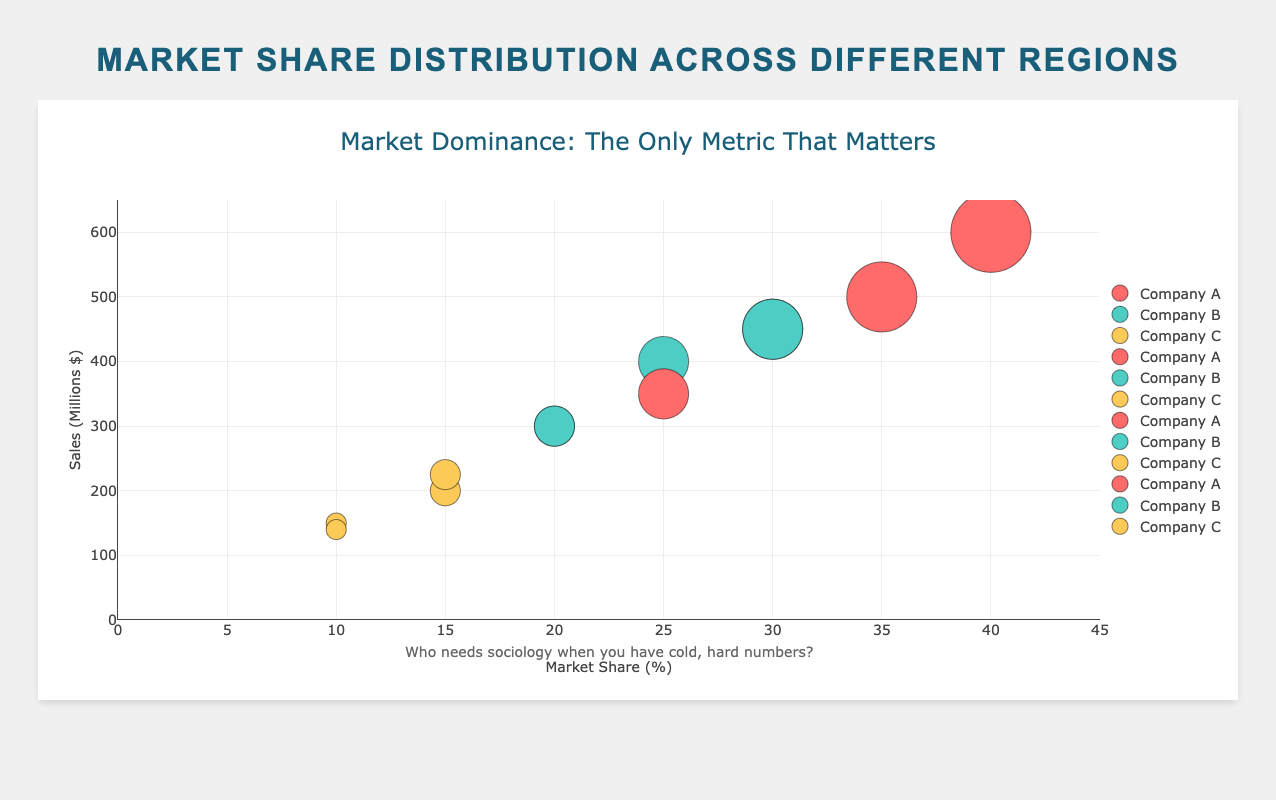What's the title of the bubble chart? The title of the chart is prominently displayed at the top, reading "Market Dominance: The Only Metric That Matters".
Answer: Market Dominance: The Only Metric That Matters What does the x-axis represent? The x-axis title is "Market Share (%)", representing the market share percentage of different companies in various regions.
Answer: Market Share (%) Which company in the "Asia" region has the highest sales? By observing the bubbles for the Asia region, Company A has the largest bubble and its tooltip shows sales of $600M, which is the highest.
Answer: Company A What is the total market share for Company B across all regions? Sum the market share percentages of Company B across all regions: 20 (North America) + 25 (Europe) + 30 (Asia) + 20 (South America) = 95%.
Answer: 95% How many regions are represented in the bubble chart? The chart includes bubbles for North America, Europe, Asia, and South America, totaling four regions.
Answer: 4 Does any company have a higher market share than Company A in any region? By examining all bubbles, no company surpasses Company A's market share in any region. Company A always has the highest market share in each region.
Answer: No Which region has the lowest sales figures overall? Looking at all the bubbles across regions, the smallest sales values are in South America, with figures of $350M, $300M, and $140M.
Answer: South America Compare the market share of Company C in North America with its market share in Europe. In the chart, Company C has a market share of 15% in North America and 10% in Europe.
Answer: 15% > 10% What is the difference in sales between Company A and Company C in North America? Company A has $500M and Company C has $200M in sales in North America; the difference is $500M - $200M = $300M.
Answer: $300M Is there a company that maintains a consistent market share across multiple regions? On examining the market shares, Company B has relatively consistent shares, with values of 20% (North America), 25% (Europe), 30% (Asia), and 20% (South America).
Answer: Yes 